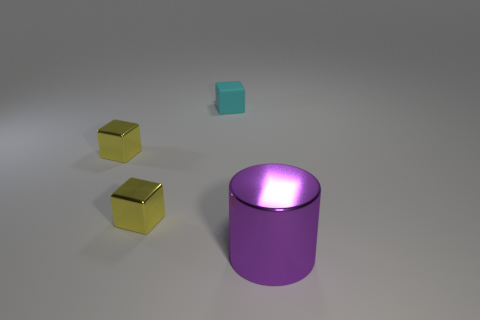Are the cyan block and the thing that is to the right of the cyan matte thing made of the same material?
Your answer should be compact. No. There is a metal thing that is to the right of the small rubber block; is it the same shape as the cyan matte object?
Give a very brief answer. No. How many other large things have the same material as the purple thing?
Keep it short and to the point. 0. How many objects are either things in front of the tiny cyan block or cyan objects?
Keep it short and to the point. 4. What is the size of the rubber object?
Give a very brief answer. Small. Is the size of the object right of the rubber block the same as the small cyan thing?
Provide a short and direct response. No. Are there any tiny objects of the same color as the big metal thing?
Make the answer very short. No. How many things are either objects that are on the left side of the large purple thing or cubes on the left side of the cyan rubber object?
Provide a succinct answer. 3. Is the number of tiny matte things that are to the right of the purple shiny cylinder less than the number of yellow cubes in front of the tiny cyan rubber block?
Keep it short and to the point. Yes. What number of other objects are the same material as the small cyan block?
Offer a very short reply. 0. 